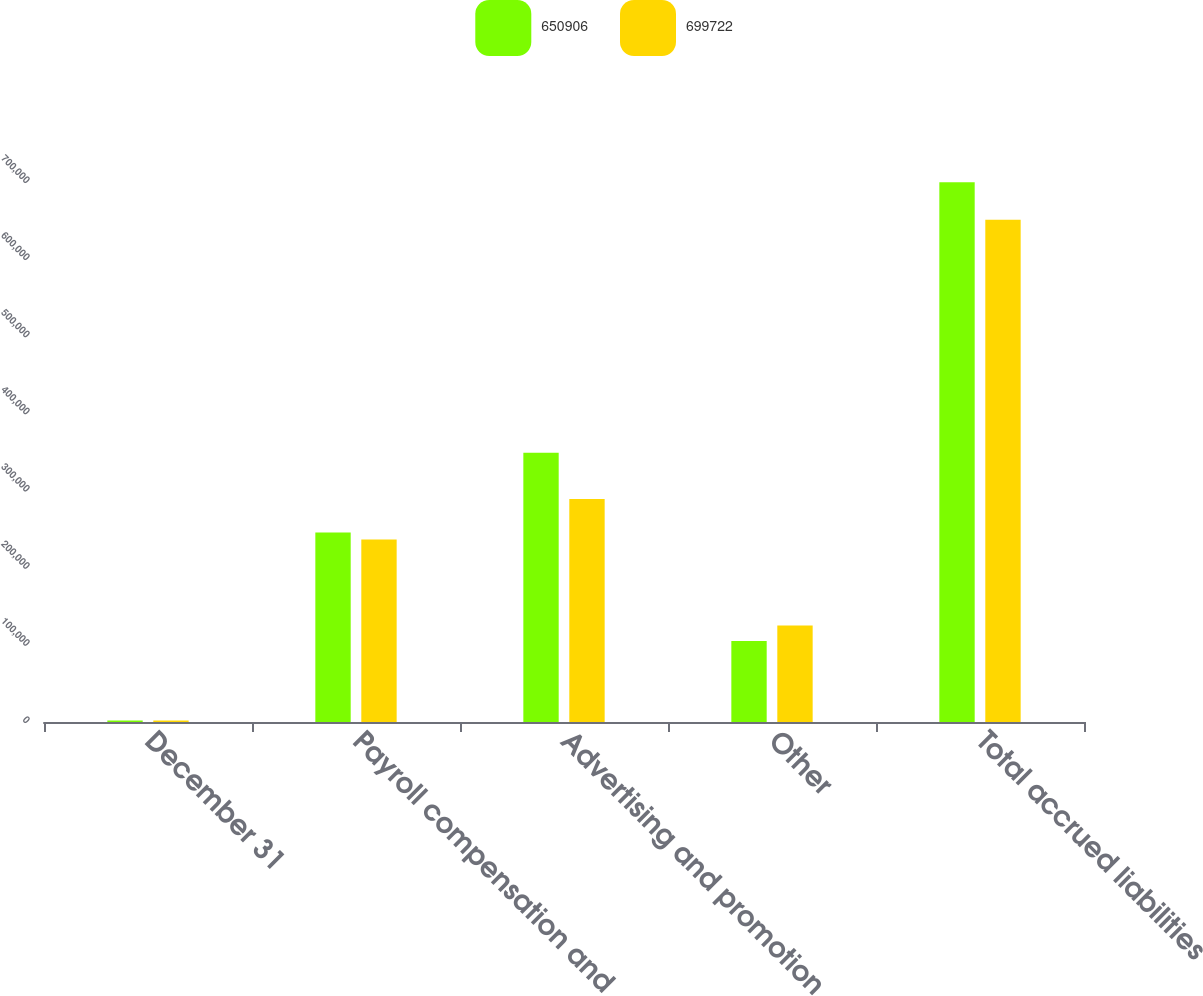Convert chart. <chart><loc_0><loc_0><loc_500><loc_500><stacked_bar_chart><ecel><fcel>December 31<fcel>Payroll compensation and<fcel>Advertising and promotion<fcel>Other<fcel>Total accrued liabilities<nl><fcel>650906<fcel>2013<fcel>245641<fcel>348966<fcel>105115<fcel>699722<nl><fcel>699722<fcel>2012<fcel>236598<fcel>289221<fcel>125087<fcel>650906<nl></chart> 